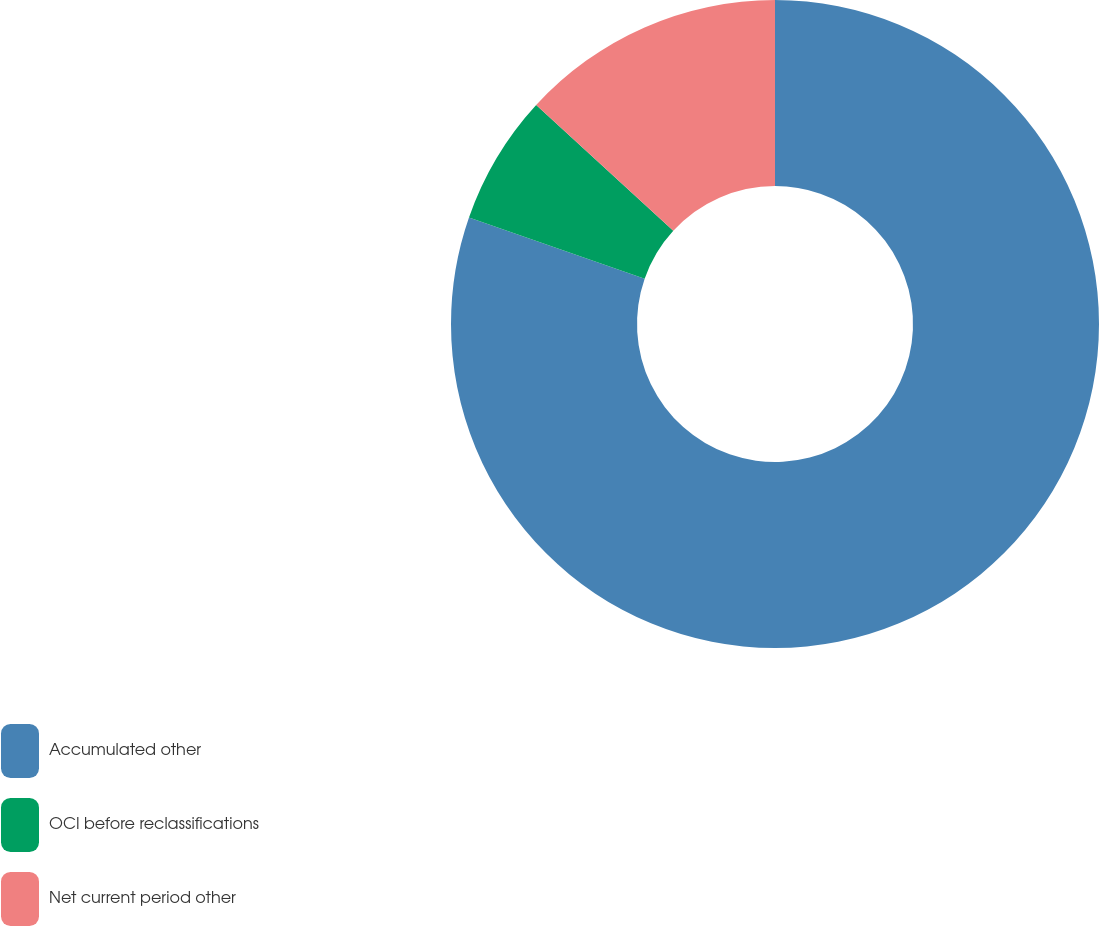Convert chart. <chart><loc_0><loc_0><loc_500><loc_500><pie_chart><fcel>Accumulated other<fcel>OCI before reclassifications<fcel>Net current period other<nl><fcel>80.32%<fcel>6.48%<fcel>13.19%<nl></chart> 